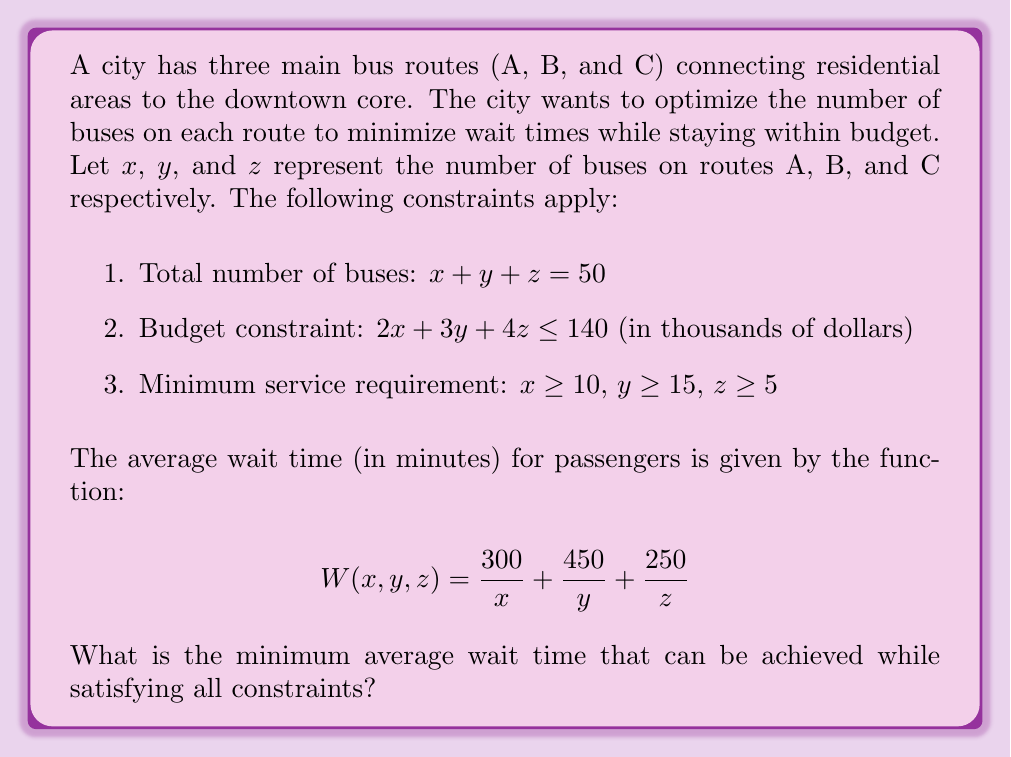Show me your answer to this math problem. To solve this optimization problem, we'll follow these steps:

1) First, we need to find the feasible region that satisfies all constraints:
   $x + y + z = 50$
   $2x + 3y + 4z \leq 140$
   $x \geq 10$, $y \geq 15$, $z \geq 5$

2) The objective is to minimize the wait time function:
   $$W(x,y,z) = \frac{300}{x} + \frac{450}{y} + \frac{250}{z}$$

3) This is a non-linear optimization problem with linear constraints. We can solve it using the method of Lagrange multipliers or numerical optimization techniques.

4) However, given the constraints, we can make an educated guess that the optimal solution will occur when the budget constraint is fully utilized (as this allows for the maximum number of buses).

5) So, we can replace the inequality in the budget constraint with an equality:
   $2x + 3y + 4z = 140$

6) Now we have a system of two equations with three variables:
   $x + y + z = 50$
   $2x + 3y + 4z = 140$

7) Solving this system (considering the minimum service requirements):
   $x = 20$, $y = 20$, $z = 10$

8) We can verify that this solution satisfies all constraints:
   - Total buses: $20 + 20 + 10 = 50$
   - Budget: $2(20) + 3(20) + 4(10) = 140$
   - Minimum service: $20 \geq 10$, $20 \geq 15$, $10 \geq 5$

9) Calculating the wait time with these values:
   $$W(20,20,10) = \frac{300}{20} + \frac{450}{20} + \frac{250}{10} = 15 + 22.5 + 25 = 62.5$$

Therefore, the minimum average wait time that can be achieved while satisfying all constraints is 62.5 minutes.
Answer: 62.5 minutes 